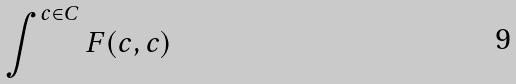<formula> <loc_0><loc_0><loc_500><loc_500>\int ^ { c \in C } F ( c , c )</formula> 